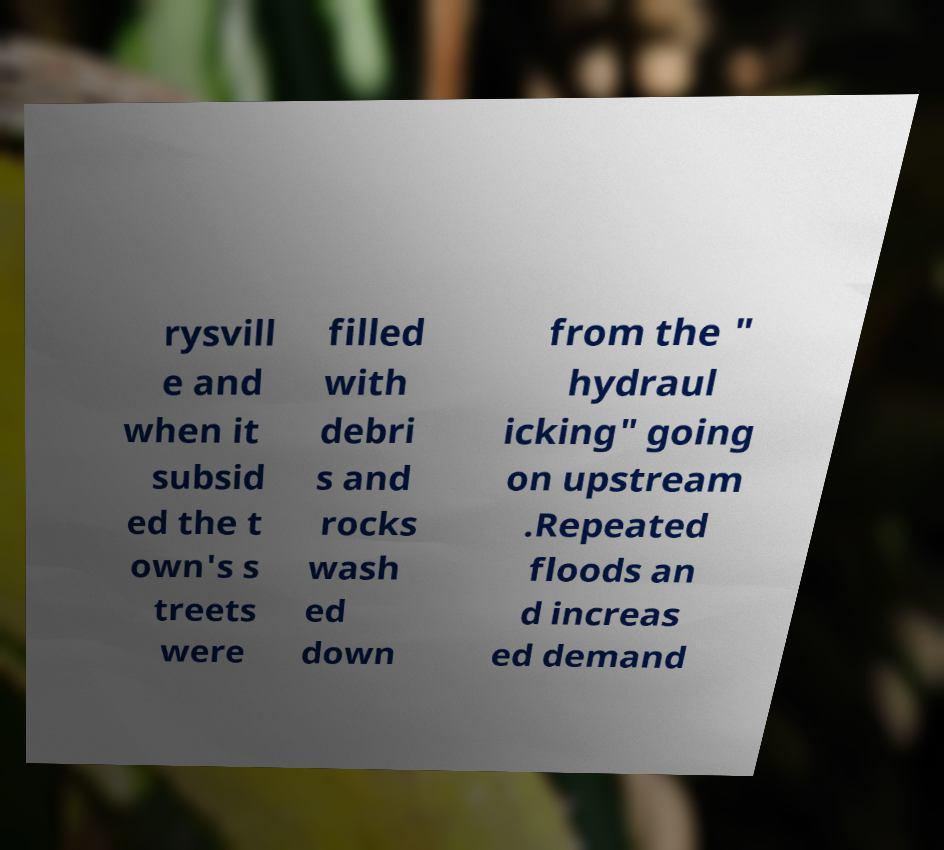Can you read and provide the text displayed in the image?This photo seems to have some interesting text. Can you extract and type it out for me? rysvill e and when it subsid ed the t own's s treets were filled with debri s and rocks wash ed down from the " hydraul icking" going on upstream .Repeated floods an d increas ed demand 